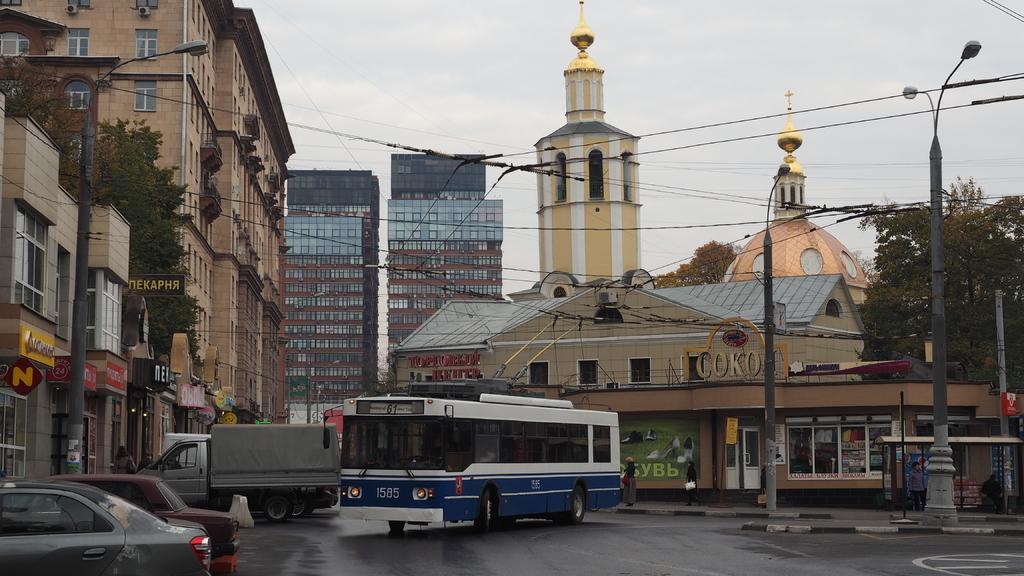Please provide a concise description of this image. There are vehicles on the road. Here we can see poles, trees, buildings, boards, and lights. In the background there is sky. 